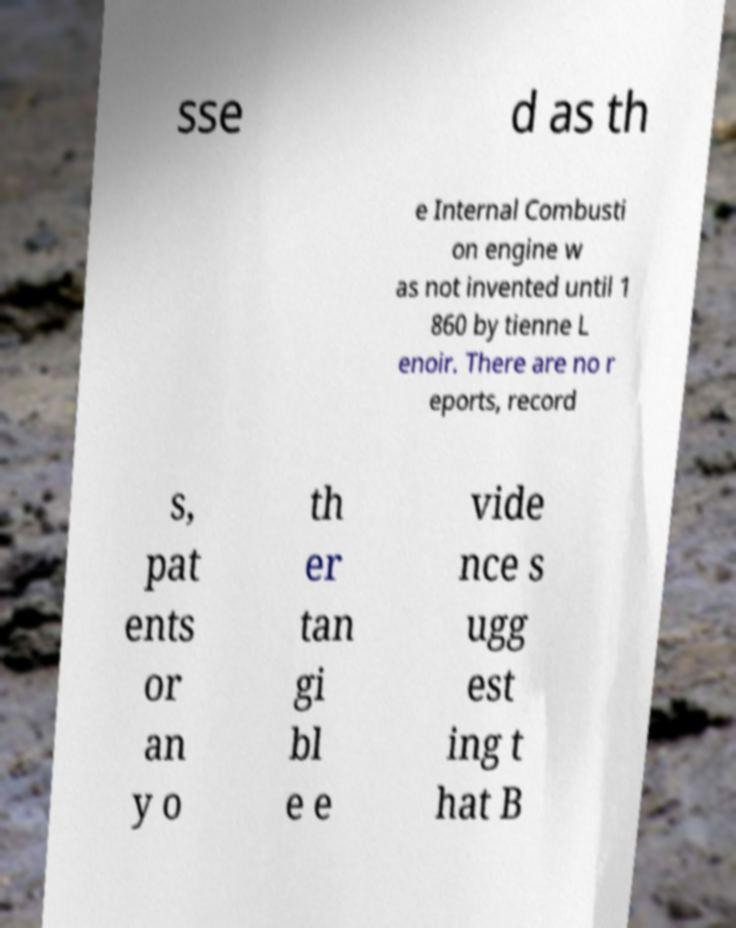Can you read and provide the text displayed in the image?This photo seems to have some interesting text. Can you extract and type it out for me? sse d as th e Internal Combusti on engine w as not invented until 1 860 by tienne L enoir. There are no r eports, record s, pat ents or an y o th er tan gi bl e e vide nce s ugg est ing t hat B 